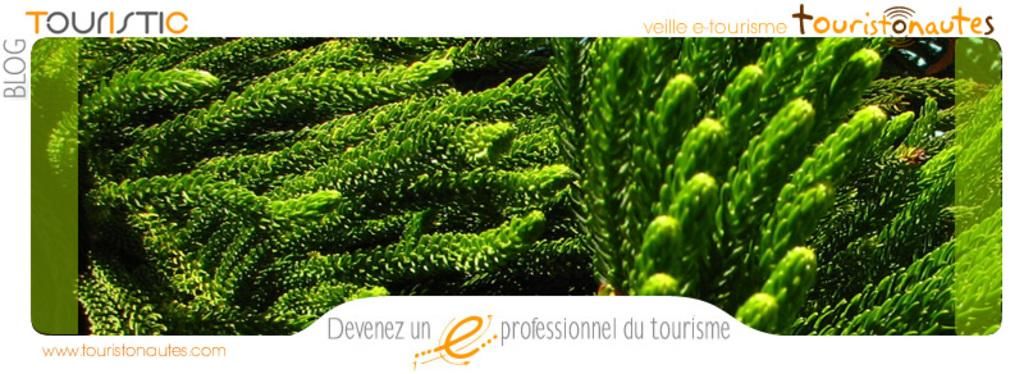What is featured on the poster in the image? There is a poster in the image, and it has an image of plants. What additional information is provided on the poster? The name "tourist" is written on the poster. How many apples are hanging from the hook in the image? There is no hook or apple present in the image. 